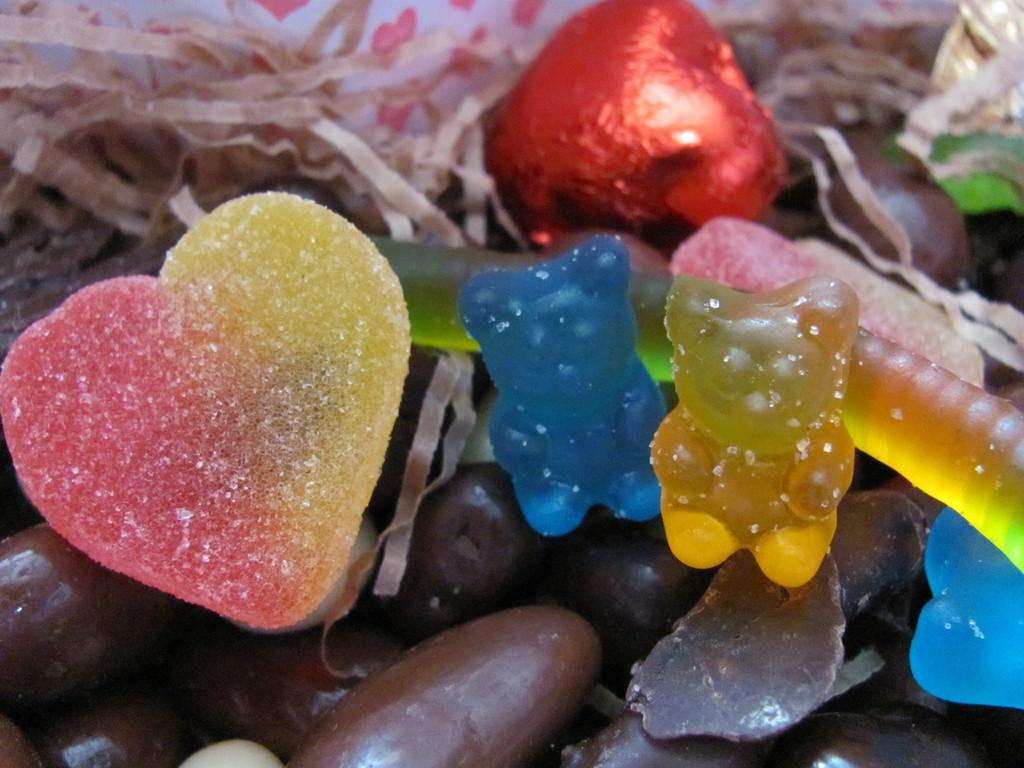What types of sweets are present in the image? There are candies and chocolates in the image. Can you describe the appearance of the candies and chocolates? The candies and chocolates have different colors. What arithmetic problem can be solved using the candies and chocolates in the image? There is no arithmetic problem present in the image, as it only features candies and chocolates. 